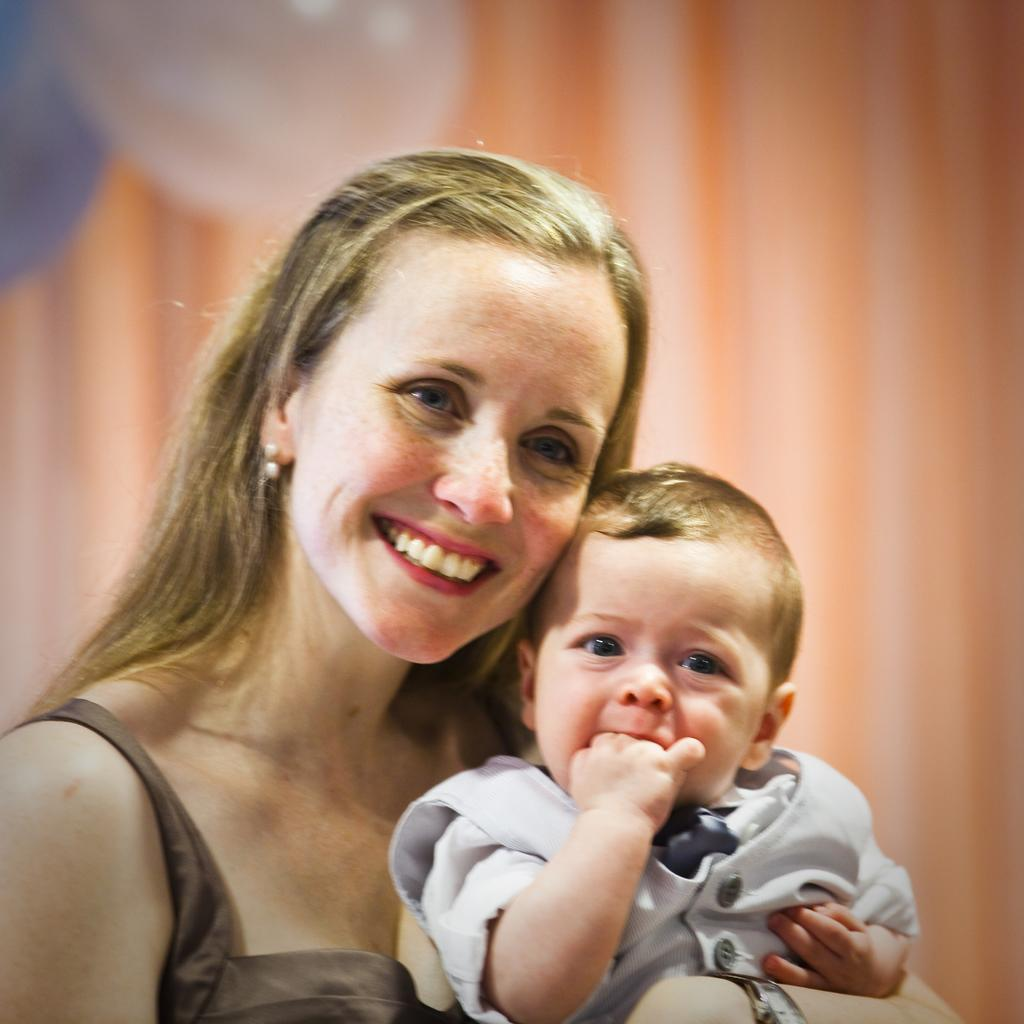Who is present in the image? There is a woman in the image. What is the woman doing in the image? The woman is holding a kid and smiling. What can be seen in the background of the image? There are two balloons and a curtain in the background of the image. What type of wood can be seen in the image? There is no wood present in the image. Is the woman in jail in the image? There is no indication of a jail or any confinement in the image. 